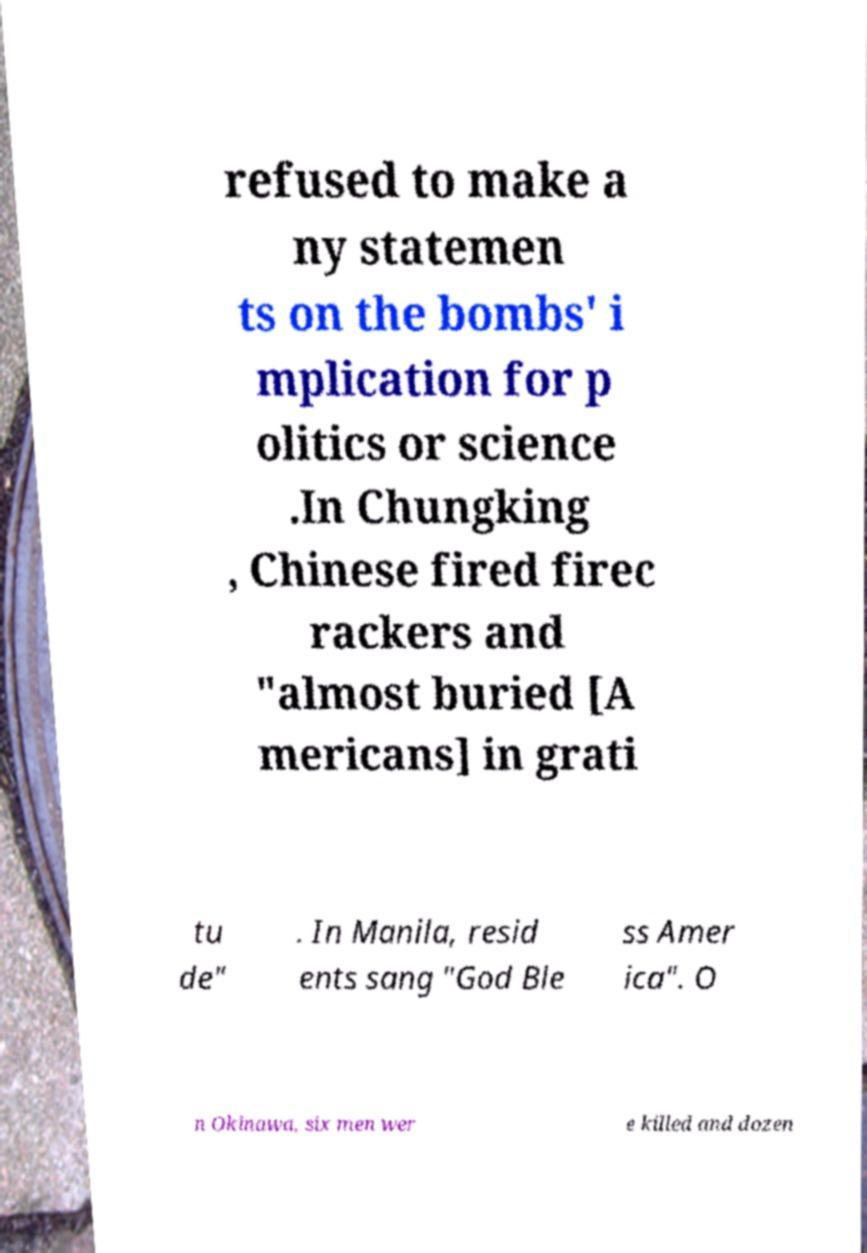Please read and relay the text visible in this image. What does it say? refused to make a ny statemen ts on the bombs' i mplication for p olitics or science .In Chungking , Chinese fired firec rackers and "almost buried [A mericans] in grati tu de" . In Manila, resid ents sang "God Ble ss Amer ica". O n Okinawa, six men wer e killed and dozen 